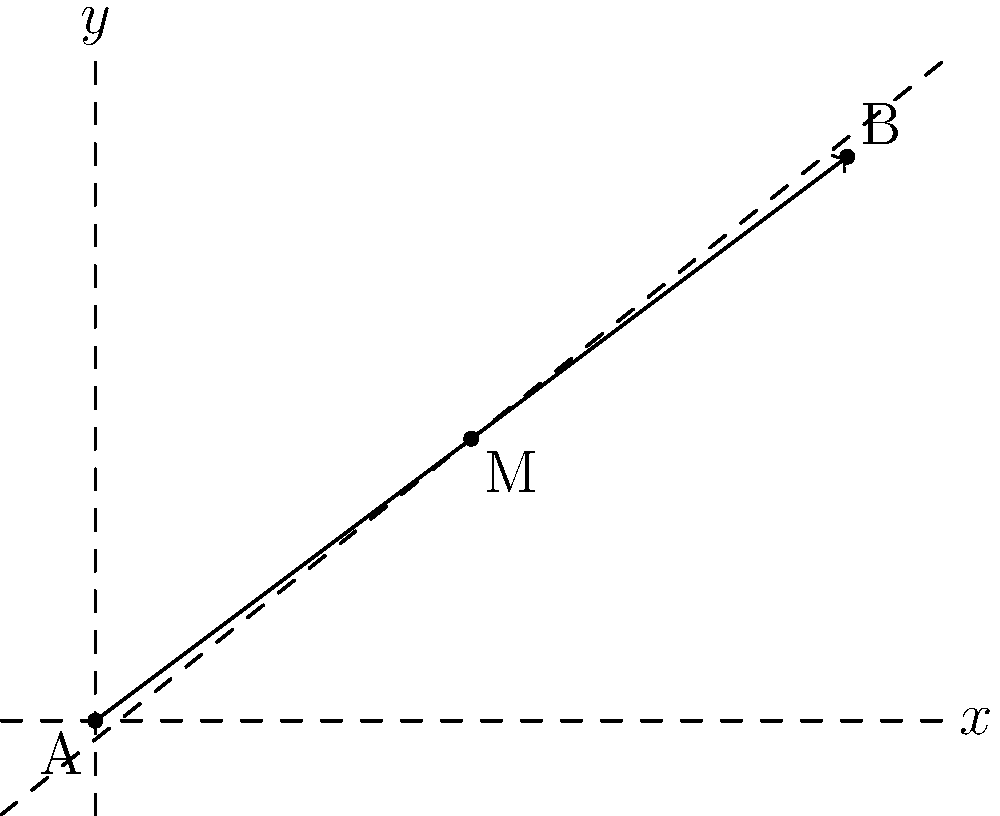During a training session, you make a long pass from point A(0,0) to your teammate at point B(8,6) on the coordinate plane. Find the coordinates of the midpoint M of this pass, representing the optimal interception point for an opposing player. To find the midpoint M of the line segment AB, we can use the midpoint formula:

$$ M = (\frac{x_1 + x_2}{2}, \frac{y_1 + y_2}{2}) $$

Where $(x_1, y_1)$ are the coordinates of point A, and $(x_2, y_2)$ are the coordinates of point B.

Given:
- Point A: (0, 0)
- Point B: (8, 6)

Step 1: Calculate the x-coordinate of the midpoint:
$$ x_M = \frac{x_1 + x_2}{2} = \frac{0 + 8}{2} = \frac{8}{2} = 4 $$

Step 2: Calculate the y-coordinate of the midpoint:
$$ y_M = \frac{y_1 + y_2}{2} = \frac{0 + 6}{2} = \frac{6}{2} = 3 $$

Therefore, the coordinates of the midpoint M are (4, 3).
Answer: (4, 3) 